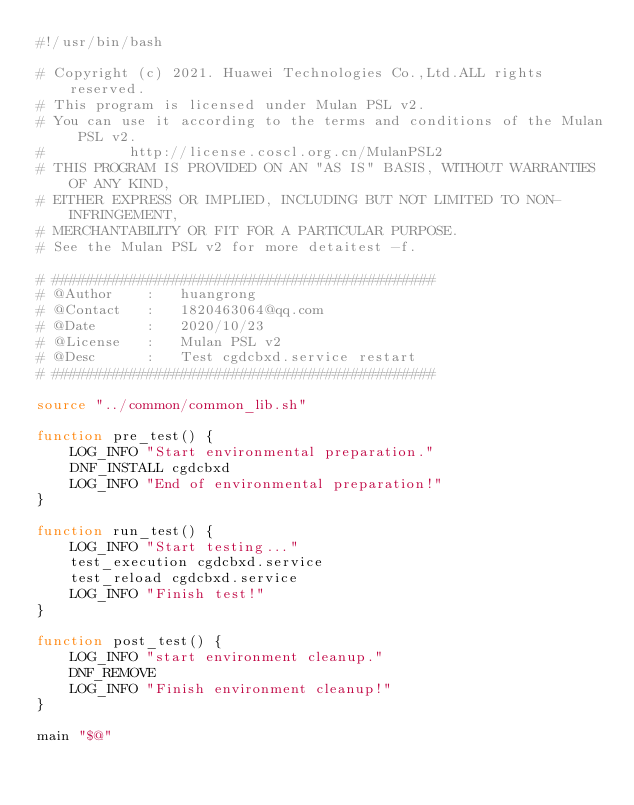<code> <loc_0><loc_0><loc_500><loc_500><_Bash_>#!/usr/bin/bash

# Copyright (c) 2021. Huawei Technologies Co.,Ltd.ALL rights reserved.
# This program is licensed under Mulan PSL v2.
# You can use it according to the terms and conditions of the Mulan PSL v2.
#          http://license.coscl.org.cn/MulanPSL2
# THIS PROGRAM IS PROVIDED ON AN "AS IS" BASIS, WITHOUT WARRANTIES OF ANY KIND,
# EITHER EXPRESS OR IMPLIED, INCLUDING BUT NOT LIMITED TO NON-INFRINGEMENT,
# MERCHANTABILITY OR FIT FOR A PARTICULAR PURPOSE.
# See the Mulan PSL v2 for more detaitest -f.

# #############################################
# @Author    :   huangrong
# @Contact   :   1820463064@qq.com
# @Date      :   2020/10/23
# @License   :   Mulan PSL v2
# @Desc      :   Test cgdcbxd.service restart
# #############################################

source "../common/common_lib.sh"

function pre_test() {
    LOG_INFO "Start environmental preparation."
    DNF_INSTALL cgdcbxd
    LOG_INFO "End of environmental preparation!"
}

function run_test() {
    LOG_INFO "Start testing..."
    test_execution cgdcbxd.service
    test_reload cgdcbxd.service
    LOG_INFO "Finish test!"
}

function post_test() {
    LOG_INFO "start environment cleanup."
    DNF_REMOVE
    LOG_INFO "Finish environment cleanup!"
}

main "$@"
</code> 